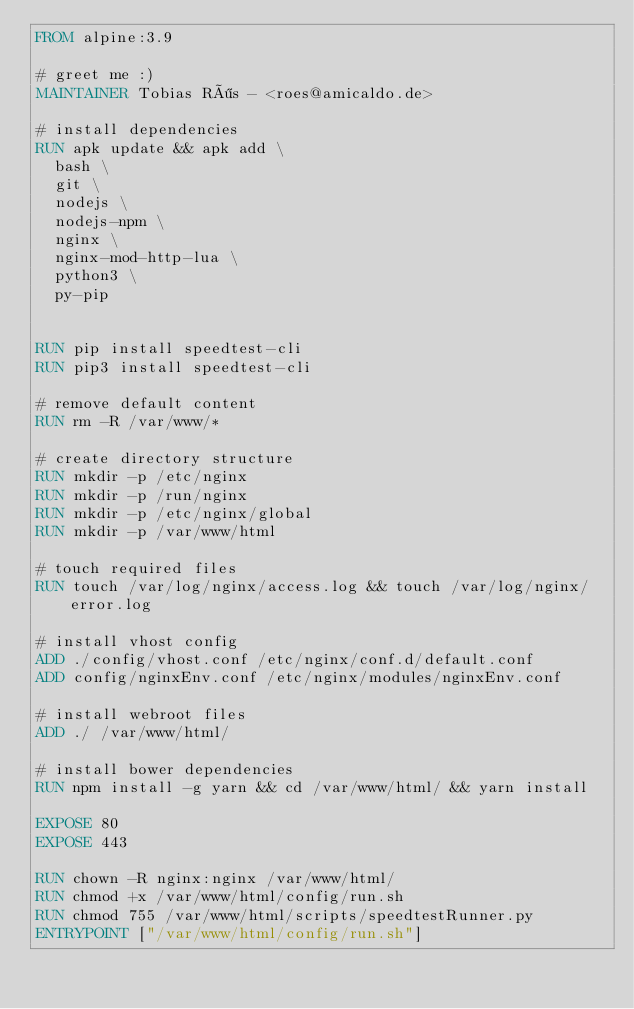<code> <loc_0><loc_0><loc_500><loc_500><_Dockerfile_>FROM alpine:3.9

# greet me :)
MAINTAINER Tobias Rös - <roes@amicaldo.de>

# install dependencies
RUN apk update && apk add \
  bash \
  git \
  nodejs \
  nodejs-npm \
  nginx \
  nginx-mod-http-lua \
  python3 \
  py-pip


RUN pip install speedtest-cli
RUN pip3 install speedtest-cli

# remove default content
RUN rm -R /var/www/*

# create directory structure
RUN mkdir -p /etc/nginx
RUN mkdir -p /run/nginx
RUN mkdir -p /etc/nginx/global
RUN mkdir -p /var/www/html

# touch required files
RUN touch /var/log/nginx/access.log && touch /var/log/nginx/error.log

# install vhost config
ADD ./config/vhost.conf /etc/nginx/conf.d/default.conf
ADD config/nginxEnv.conf /etc/nginx/modules/nginxEnv.conf

# install webroot files
ADD ./ /var/www/html/

# install bower dependencies
RUN npm install -g yarn && cd /var/www/html/ && yarn install

EXPOSE 80
EXPOSE 443

RUN chown -R nginx:nginx /var/www/html/
RUN chmod +x /var/www/html/config/run.sh
RUN chmod 755 /var/www/html/scripts/speedtestRunner.py
ENTRYPOINT ["/var/www/html/config/run.sh"]
</code> 